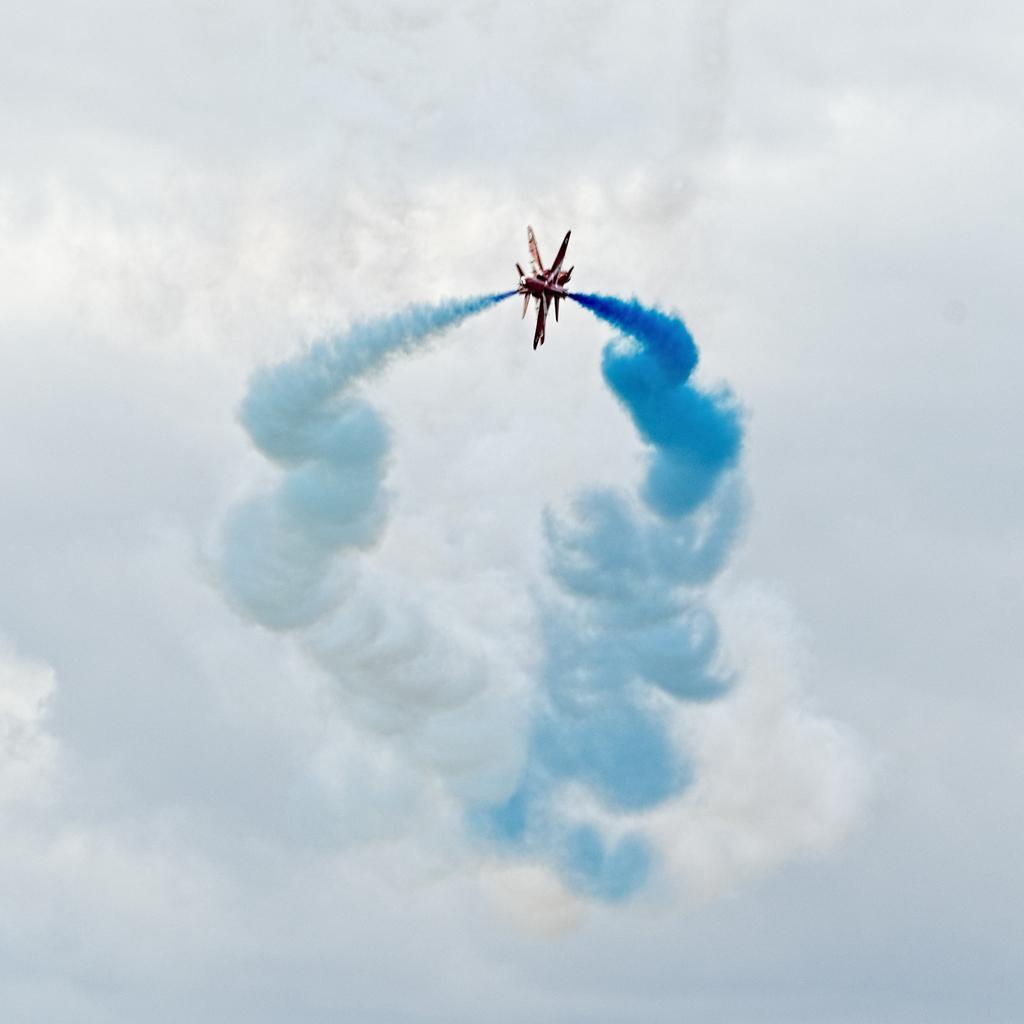How would you summarize this image in a sentence or two? In this picture we can see a flight exhaling smoke in blue color and in the background we can see the sky with clouds. 